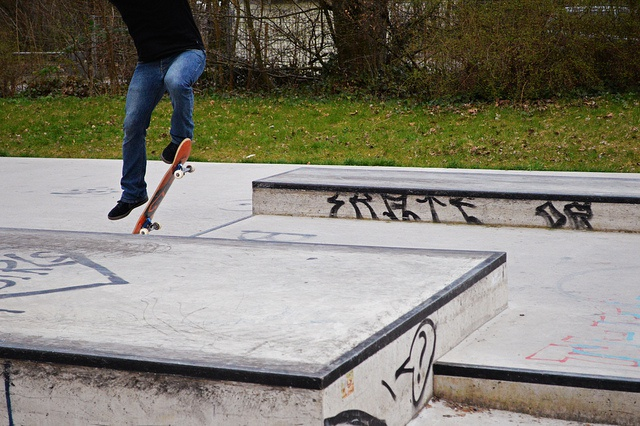Describe the objects in this image and their specific colors. I can see people in black, navy, blue, and gray tones and skateboard in black, gray, and brown tones in this image. 